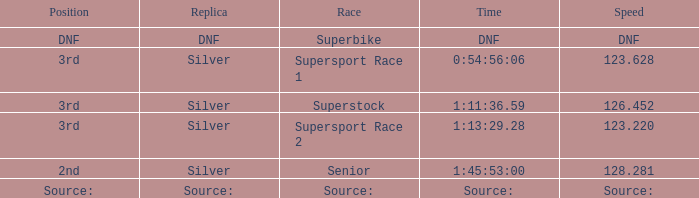Which race has a position of 3rd and a speed of 123.628? Supersport Race 1. 